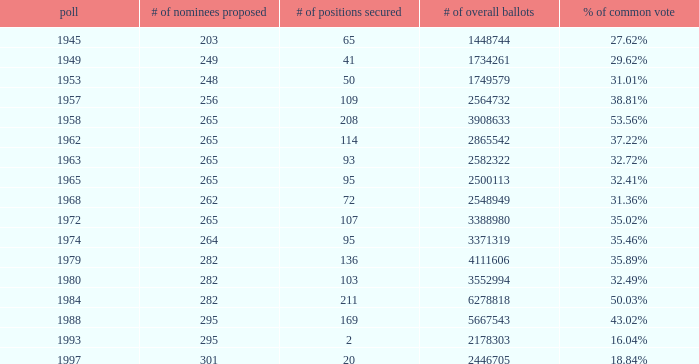What year was the election when the # of seats won was 65? 1945.0. 